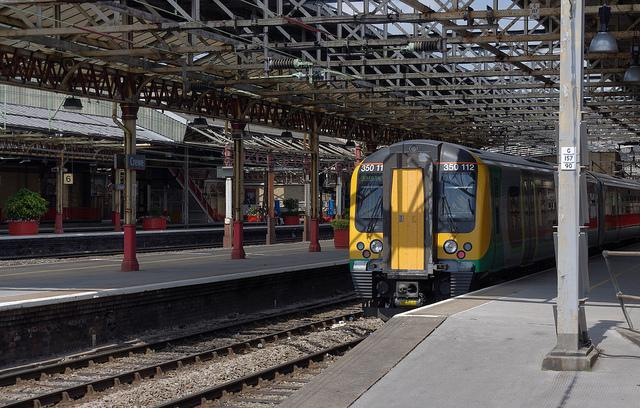Which numbers are fully visible on both the top left and top right of the front of the bus? 350 